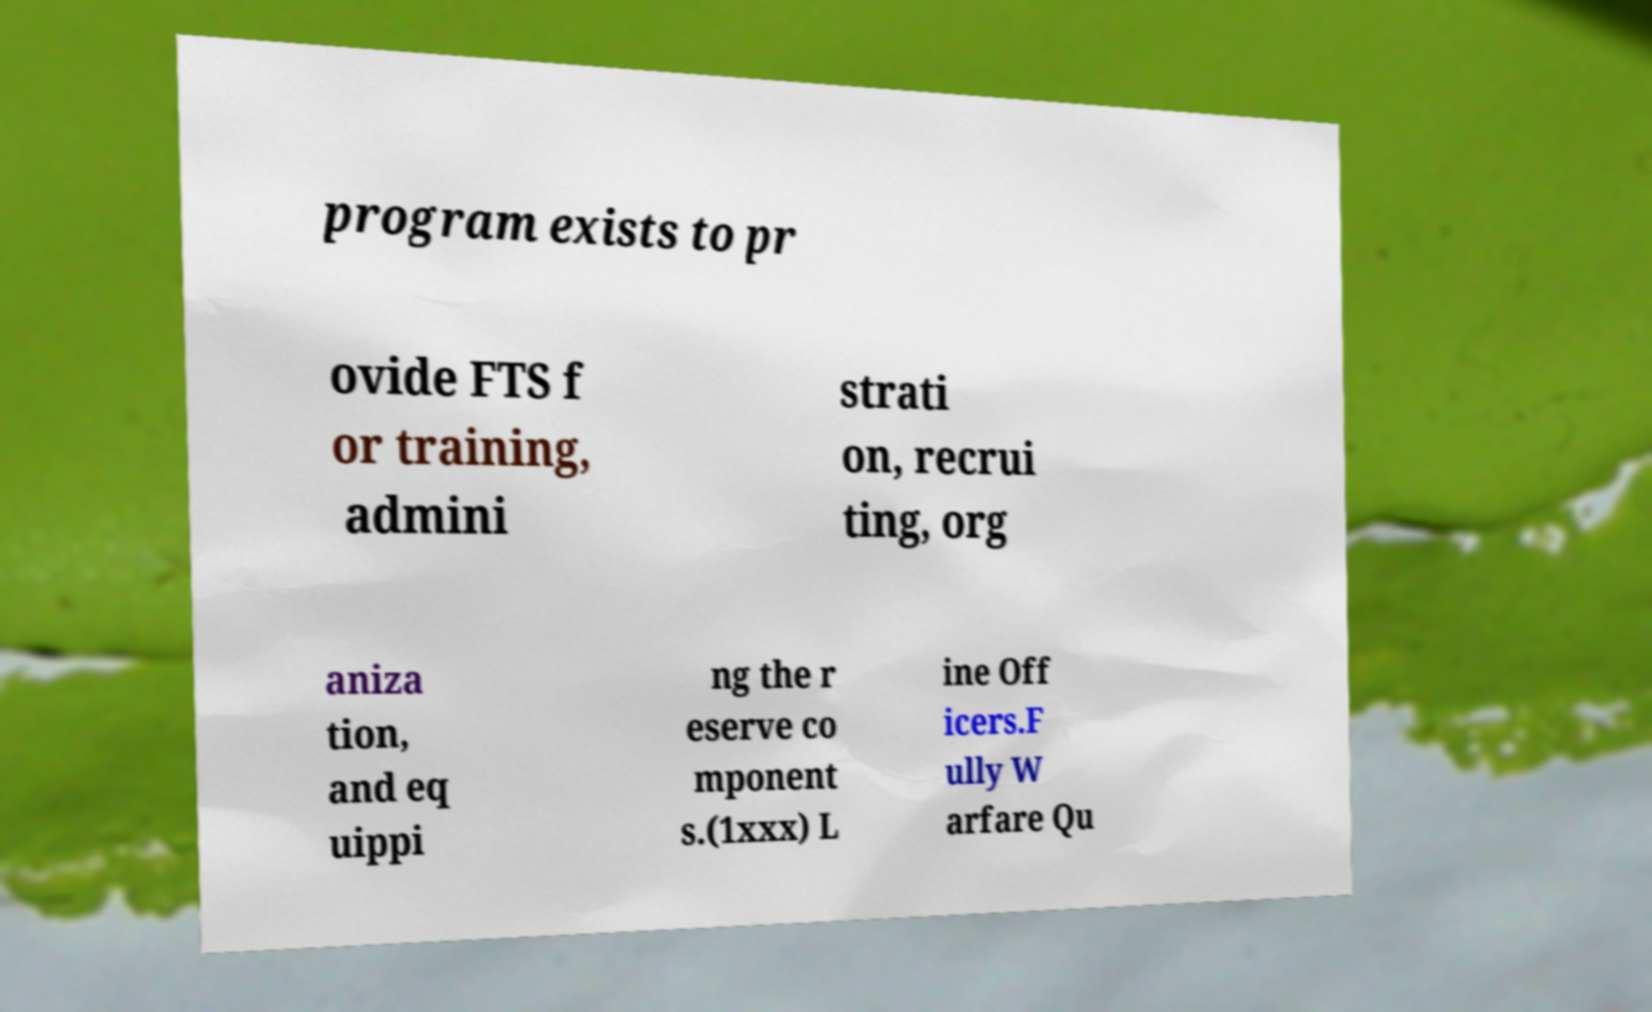Can you read and provide the text displayed in the image?This photo seems to have some interesting text. Can you extract and type it out for me? program exists to pr ovide FTS f or training, admini strati on, recrui ting, org aniza tion, and eq uippi ng the r eserve co mponent s.(1xxx) L ine Off icers.F ully W arfare Qu 